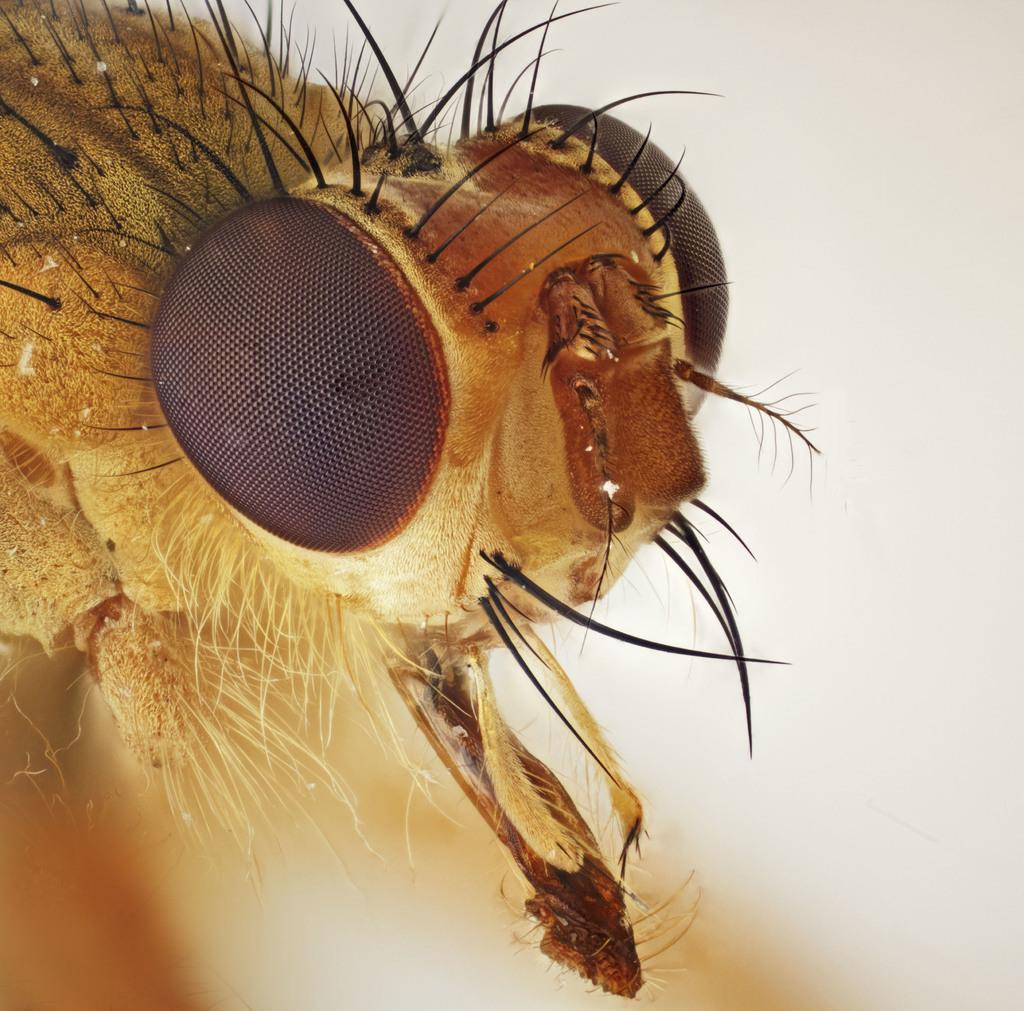What type of creature can be seen in the image? There is an insect with hairs in the image. What color is the background of the image? The background of the image is white. What type of cork is visible in the image? There is no cork present in the image. What shape is the square in the image? There is no square present in the image. 